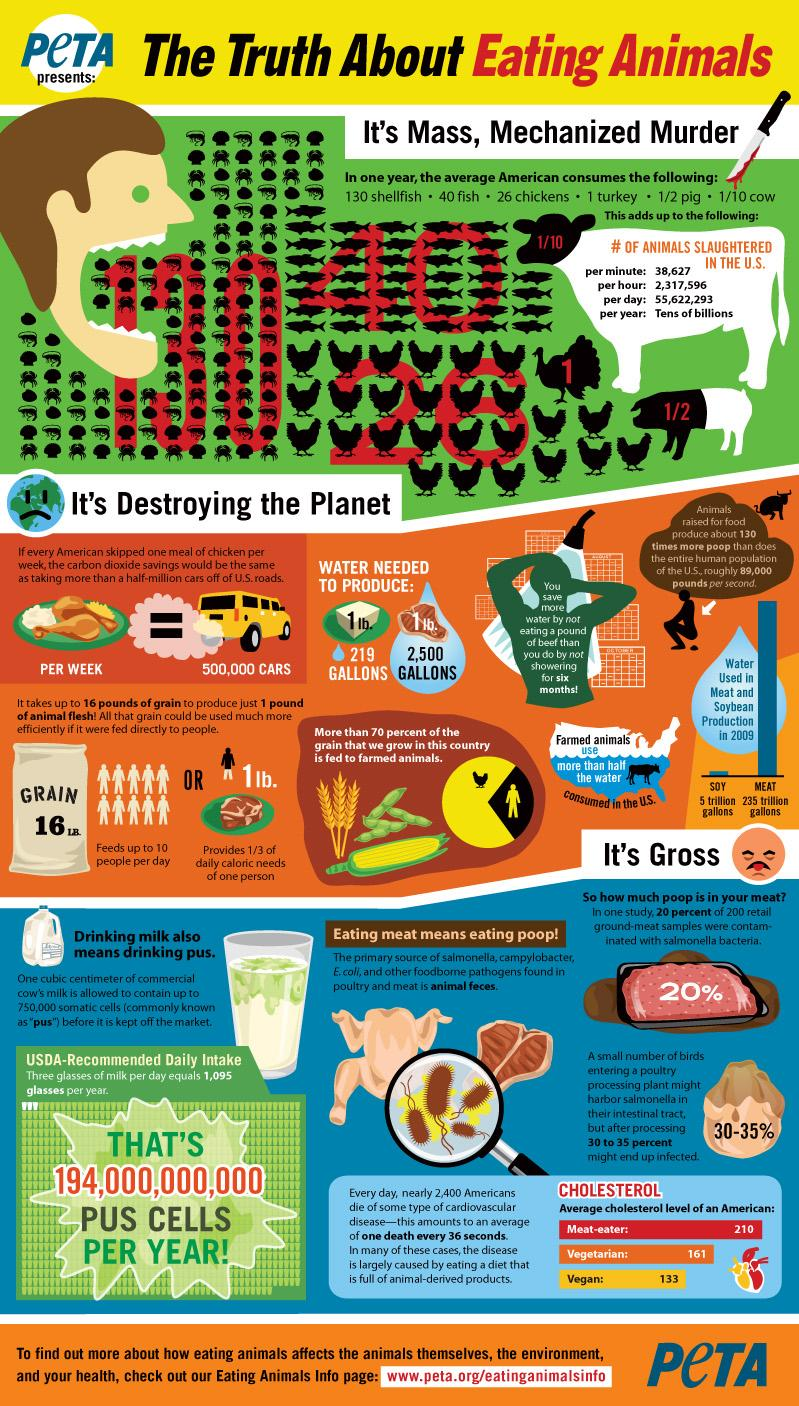Mention a couple of crucial points in this snapshot. The average American consumes a significant amount of shellfish, fish, and chicken in a year, with a precise figure of 196 pounds. According to estimates, only 30% of the grain produced globally is consumed by the population. The number written on the body of the pig is 1/2. One pound of meat provided approximately one-third of the daily caloric needs of one person. Producing 1 pound of meat requires 2,500 gallons of water, which is a significant amount of water consumption for a single serving of meat. 